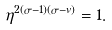<formula> <loc_0><loc_0><loc_500><loc_500>\eta ^ { 2 ( \sigma - 1 ) ( \sigma - v ) } = 1 .</formula> 